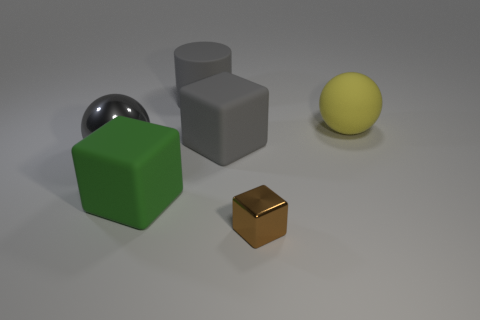Subtract all large matte cubes. How many cubes are left? 1 Add 3 green metal cylinders. How many objects exist? 9 Subtract 1 balls. How many balls are left? 1 Add 1 brown blocks. How many brown blocks are left? 2 Add 2 big matte cylinders. How many big matte cylinders exist? 3 Subtract all green blocks. How many blocks are left? 2 Subtract 0 red spheres. How many objects are left? 6 Subtract all spheres. How many objects are left? 4 Subtract all blue spheres. Subtract all red blocks. How many spheres are left? 2 Subtract all cyan cylinders. Subtract all metal cubes. How many objects are left? 5 